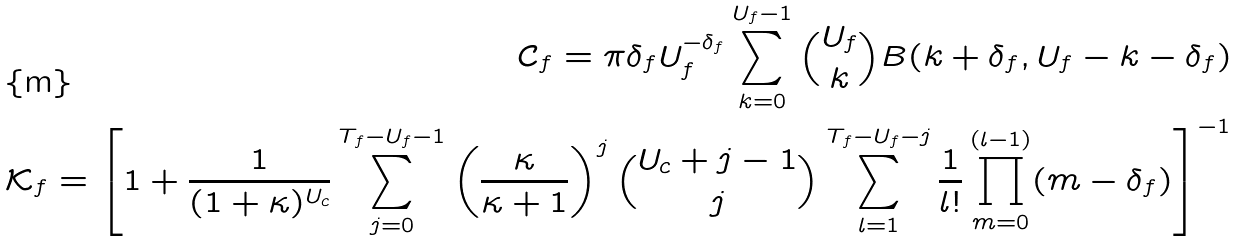<formula> <loc_0><loc_0><loc_500><loc_500>\mathcal { C } _ { f } = \pi \delta _ { f } U _ { f } ^ { - \delta _ { f } } \sum _ { k = 0 } ^ { U _ { f } - 1 } \binom { U _ { f } } { k } B ( k + \delta _ { f } , U _ { f } - k - \delta _ { f } ) \\ \mathcal { K } _ { f } = \left [ 1 + \frac { 1 } { ( 1 + \kappa ) ^ { U _ { c } } } \sum _ { j = 0 } ^ { T _ { f } - U _ { f } - 1 } \left ( \frac { \kappa } { \kappa + 1 } \right ) ^ { j } \binom { U _ { c } + j - 1 } { j } \sum _ { l = 1 } ^ { T _ { f } - U _ { f } - j } \frac { 1 } { l ! } \prod _ { m = 0 } ^ { ( l - 1 ) } ( m - \delta _ { f } ) \right ] ^ { - 1 }</formula> 